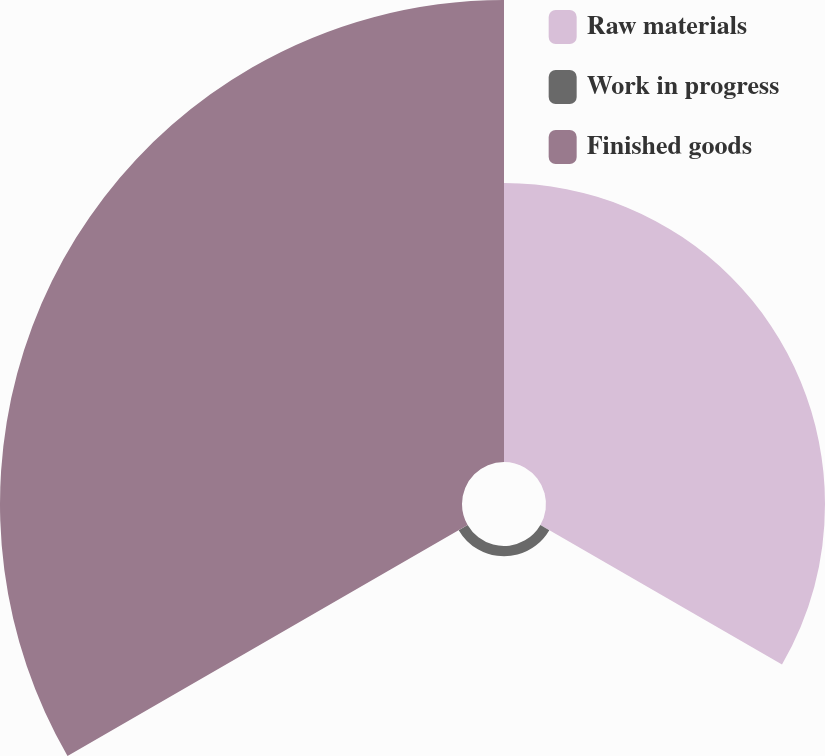<chart> <loc_0><loc_0><loc_500><loc_500><pie_chart><fcel>Raw materials<fcel>Work in progress<fcel>Finished goods<nl><fcel>37.14%<fcel>1.37%<fcel>61.5%<nl></chart> 